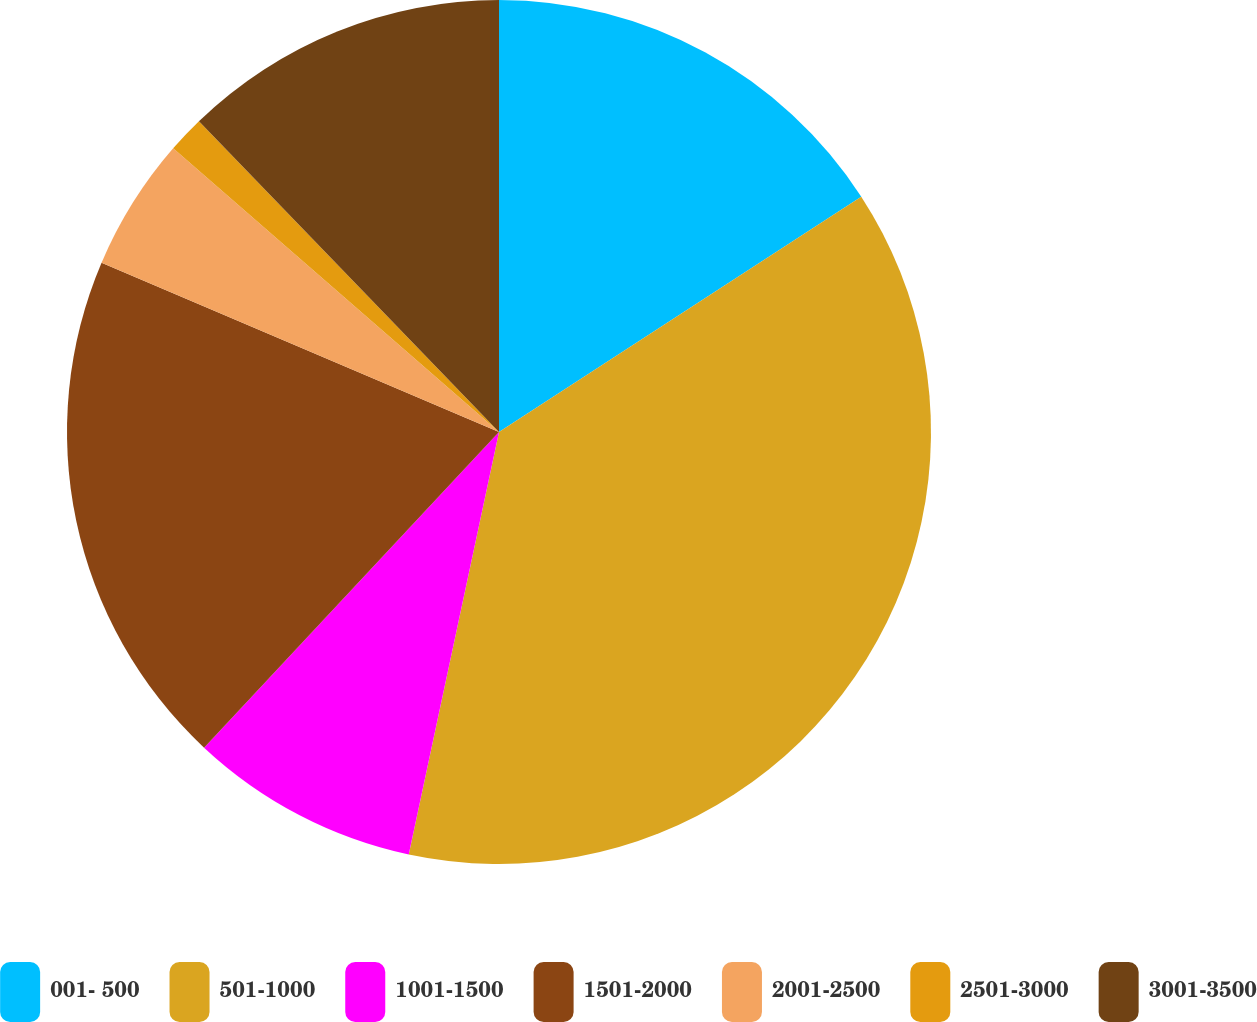Convert chart to OTSL. <chart><loc_0><loc_0><loc_500><loc_500><pie_chart><fcel>001- 500<fcel>501-1000<fcel>1001-1500<fcel>1501-2000<fcel>2001-2500<fcel>2501-3000<fcel>3001-3500<nl><fcel>15.83%<fcel>37.52%<fcel>8.61%<fcel>19.45%<fcel>4.99%<fcel>1.38%<fcel>12.22%<nl></chart> 